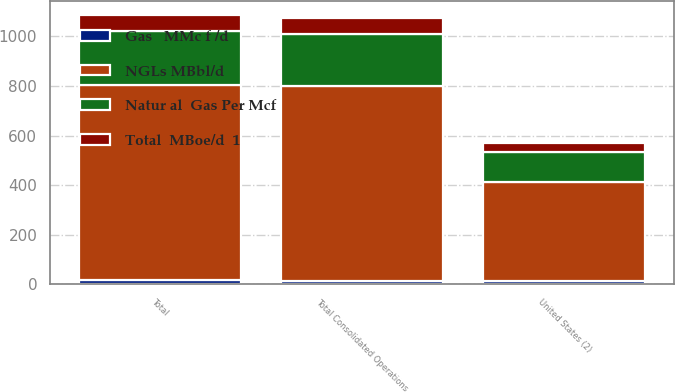<chart> <loc_0><loc_0><loc_500><loc_500><stacked_bar_chart><ecel><fcel>United States (2)<fcel>Total Consolidated Operations<fcel>Total<nl><fcel>Total  MBoe/d  1<fcel>39<fcel>64<fcel>66<nl><fcel>NGLs MBbl/d<fcel>400<fcel>787<fcel>787<nl><fcel>Gas   MMc f /d<fcel>14<fcel>14<fcel>19<nl><fcel>Natur al  Gas Per Mcf<fcel>119<fcel>209<fcel>216<nl></chart> 